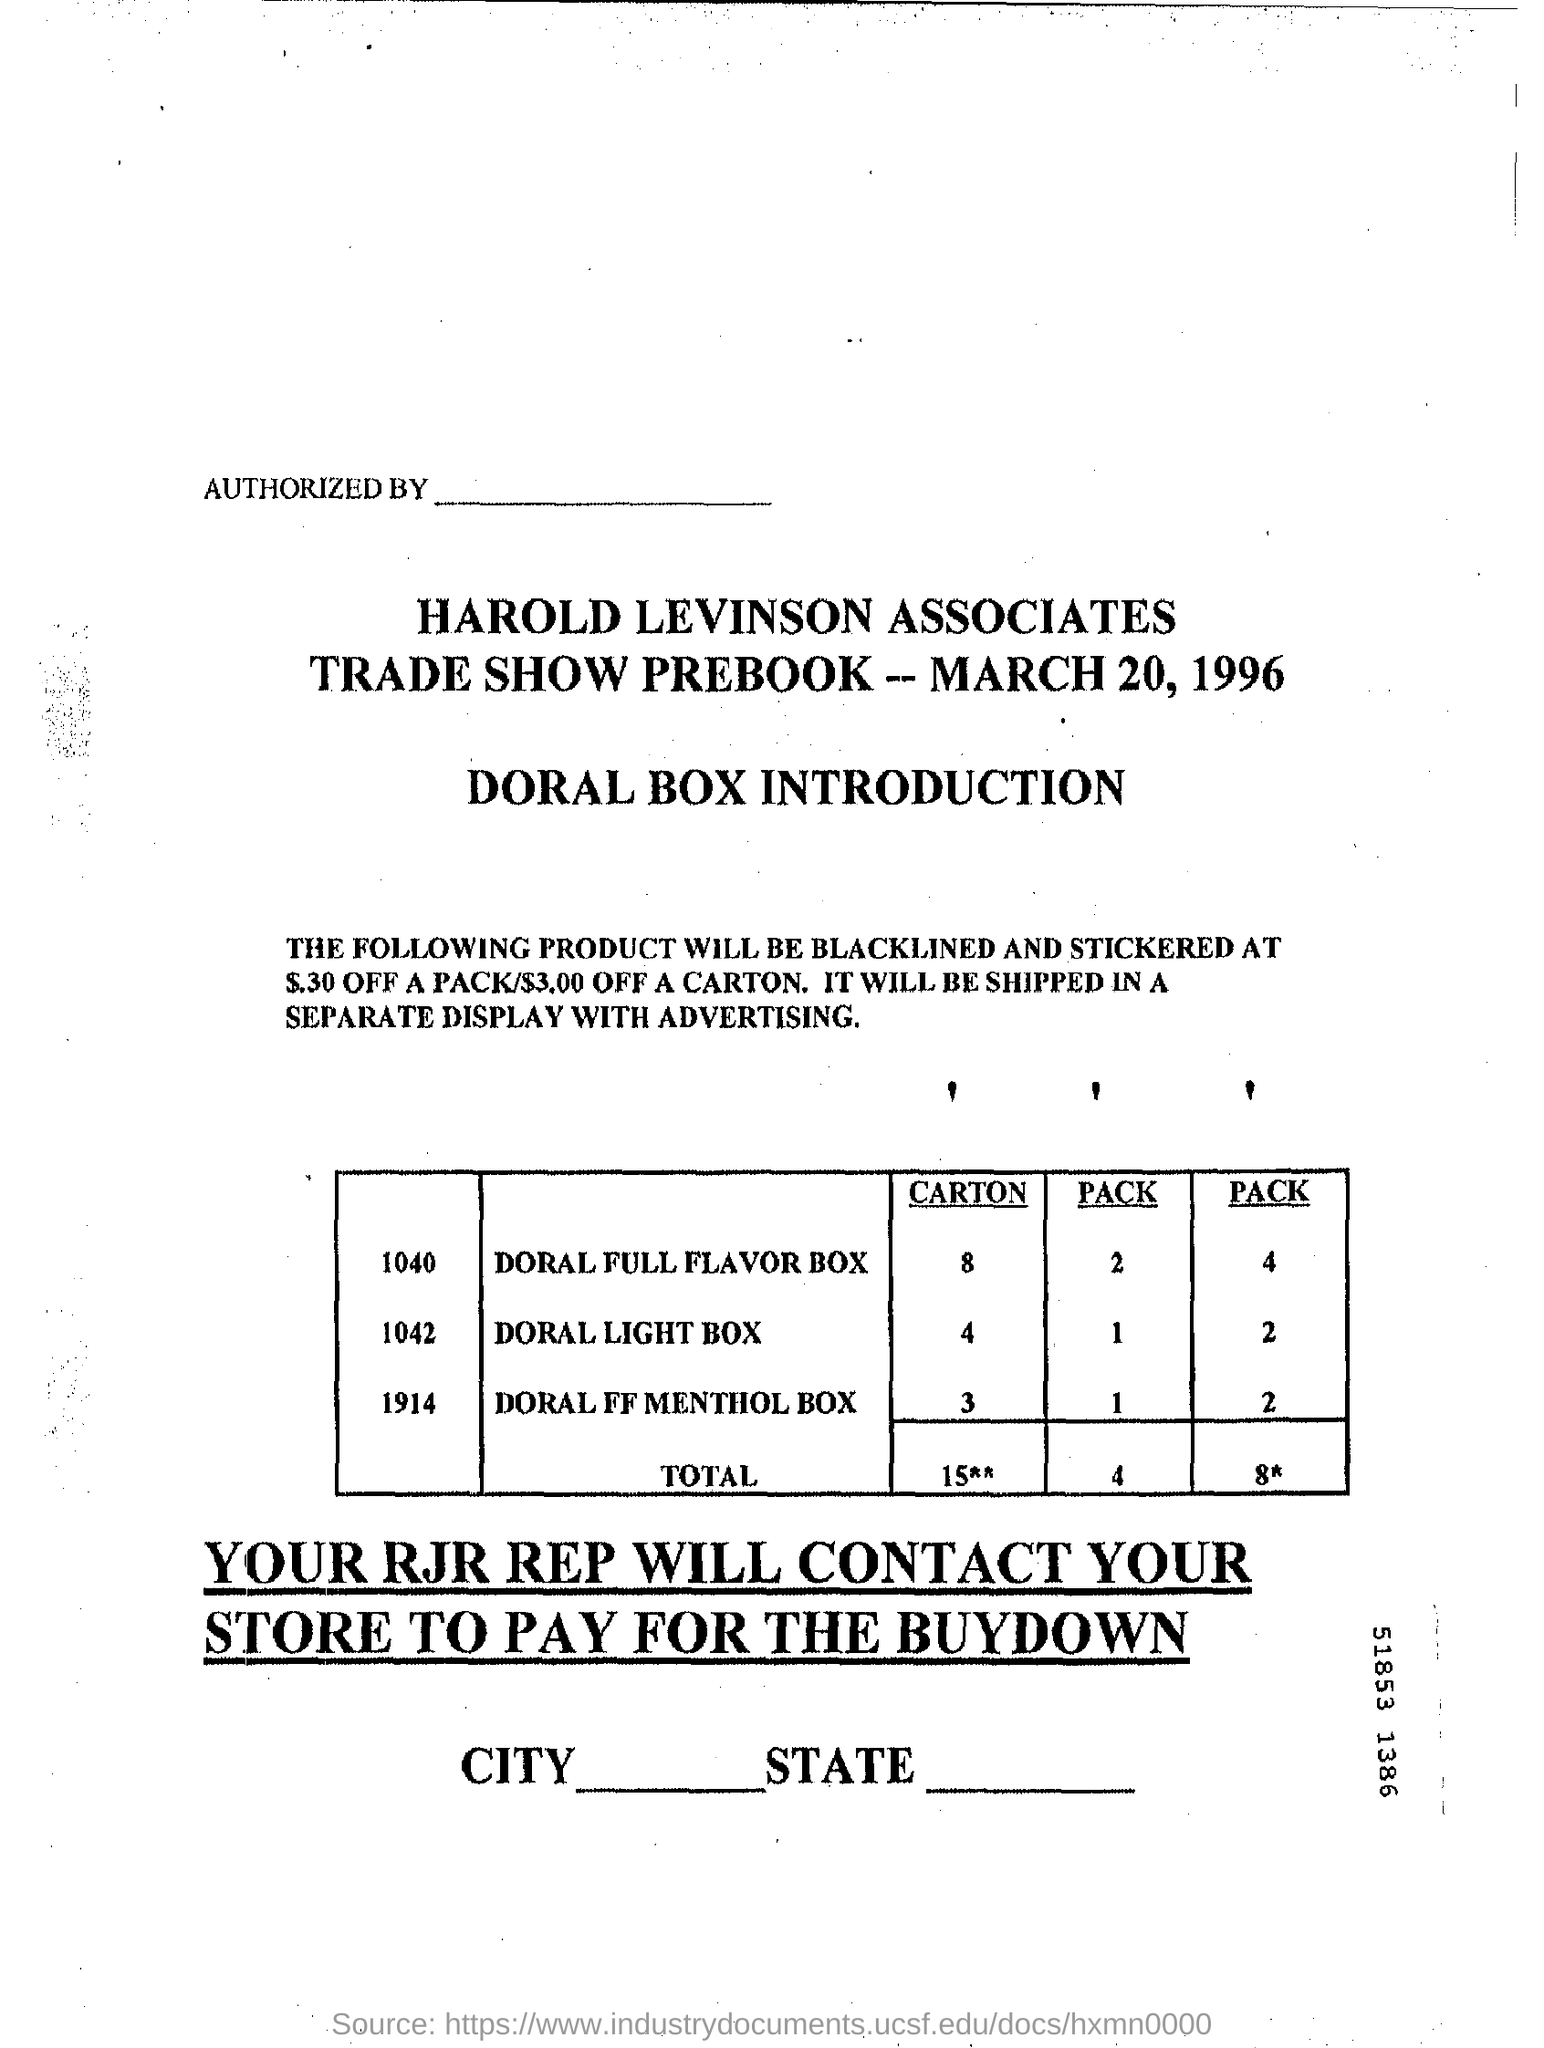Whose prebook is this?
Offer a very short reply. Harold levinson associates trade show prebook. What is the date on trade show prebook?
Ensure brevity in your answer.  March 20 , 1996. How many carton of doral light box are given in the table?
Offer a very short reply. 4. 